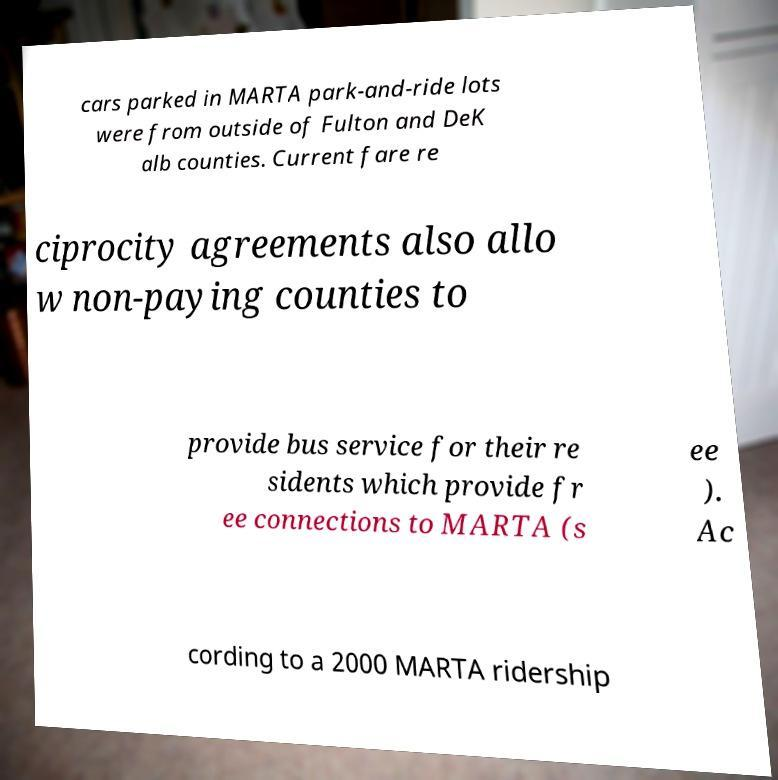Can you read and provide the text displayed in the image?This photo seems to have some interesting text. Can you extract and type it out for me? cars parked in MARTA park-and-ride lots were from outside of Fulton and DeK alb counties. Current fare re ciprocity agreements also allo w non-paying counties to provide bus service for their re sidents which provide fr ee connections to MARTA (s ee ). Ac cording to a 2000 MARTA ridership 